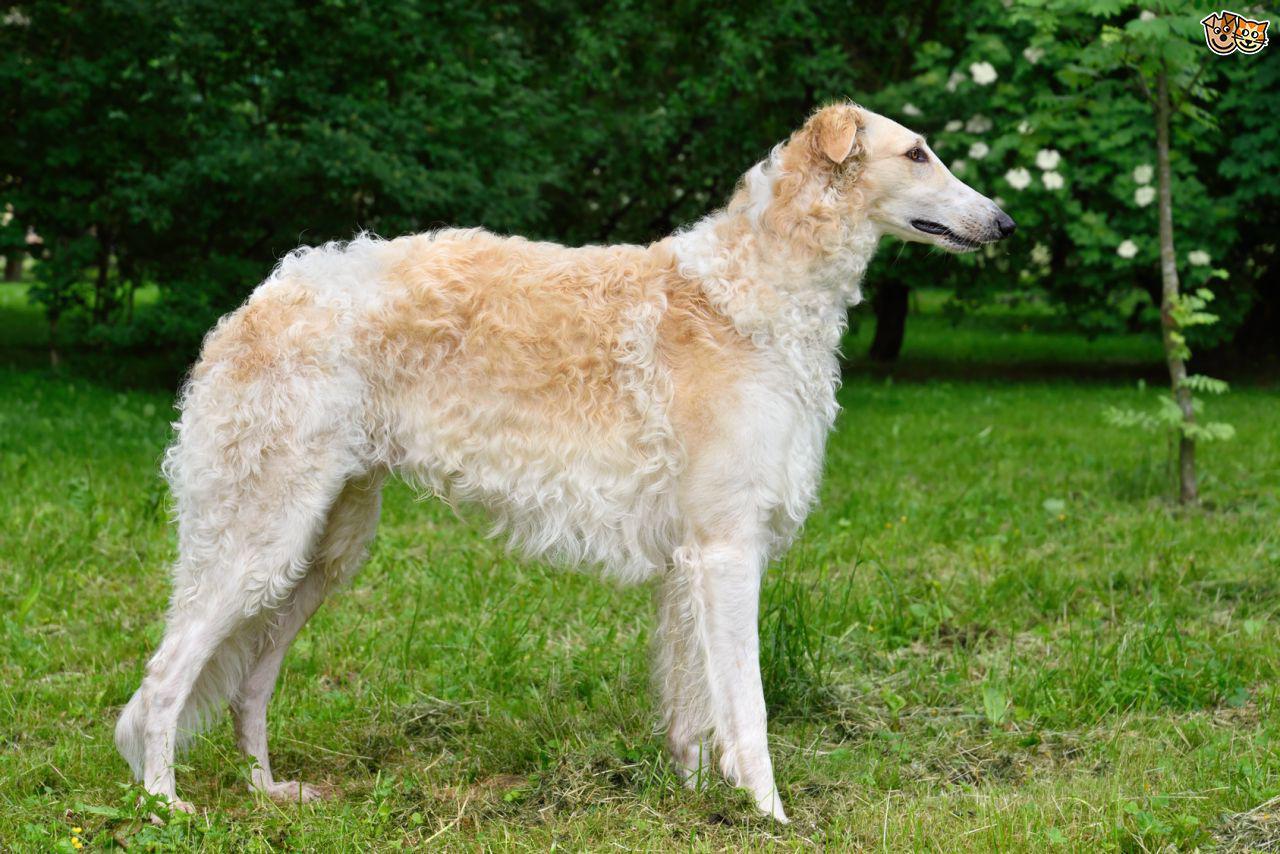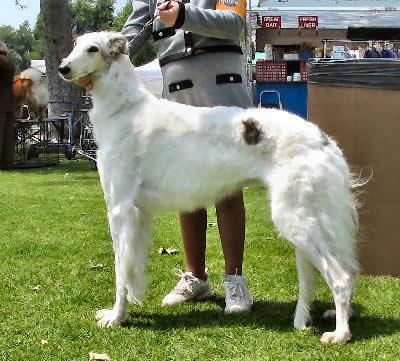The first image is the image on the left, the second image is the image on the right. Given the left and right images, does the statement "there is exactly one person in the image on the right." hold true? Answer yes or no. Yes. The first image is the image on the left, the second image is the image on the right. Analyze the images presented: Is the assertion "A person is upright near a hound in one image." valid? Answer yes or no. Yes. 